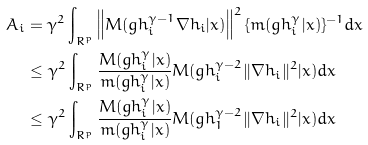<formula> <loc_0><loc_0><loc_500><loc_500>A _ { i } & = \gamma ^ { 2 } \int _ { R ^ { p } } \left \| M ( g h _ { i } ^ { \gamma - 1 } \nabla h _ { i } | x ) \right \| ^ { 2 } \{ m ( g h _ { i } ^ { \gamma } | x ) \} ^ { - 1 } d x \\ & \leq \gamma ^ { 2 } \int _ { R ^ { p } } \frac { M ( g h _ { i } ^ { \gamma } | x ) } { m ( g h _ { i } ^ { \gamma } | x ) } M ( g h _ { i } ^ { \gamma - 2 } \| \nabla h _ { i } \| ^ { 2 } | x ) d x \\ & \leq \gamma ^ { 2 } \int _ { R ^ { p } } \frac { M ( g h _ { i } ^ { \gamma } | x ) } { m ( g h _ { i } ^ { \gamma } | x ) } M ( g h _ { 1 } ^ { \gamma - 2 } \| \nabla h _ { i } \| ^ { 2 } | x ) d x</formula> 